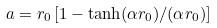<formula> <loc_0><loc_0><loc_500><loc_500>a = r _ { 0 } \left [ 1 - \tanh ( \alpha r _ { 0 } ) / ( \alpha r _ { 0 } ) \right ]</formula> 